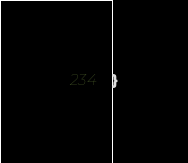Convert code to text. <code><loc_0><loc_0><loc_500><loc_500><_CSS_>}</code> 